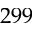Convert formula to latex. <formula><loc_0><loc_0><loc_500><loc_500>2 9 9</formula> 